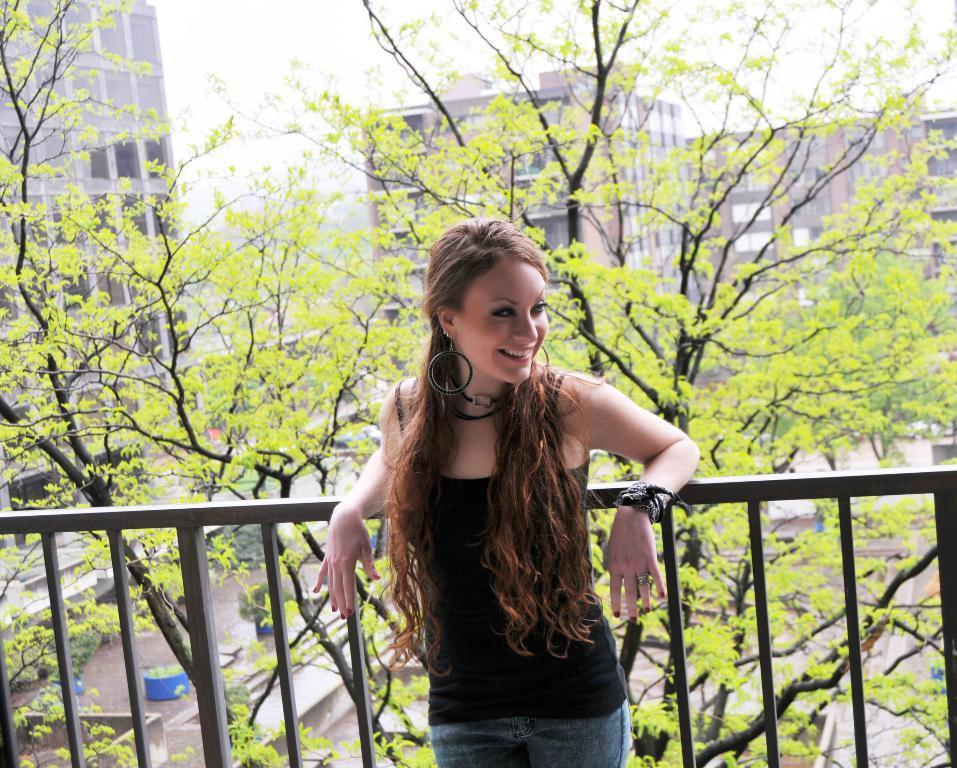What is the main subject of the image? There is a girl standing in the image. Where is the girl located in the image? The girl is at a fence. What can be seen in the background of the image? There are trees, buildings, plants in pots, and the sky visible in the background of the image. What type of seed is the girl planting in the image? There is no seed or planting activity depicted in the image; the girl is simply standing at a fence. Can you tell me where the nearest library is in relation to the girl in the image? The provided facts do not mention a library or its location in relation to the girl in the image. --- Facts: 1. There is a car in the image. 2. The car is parked on the street. 3. There are people walking on the sidewalk. 4. There are trees lining the street. 5. The sky is visible in the image. Absurd Topics: fish, volcano, parachute Conversation: What is the main subject of the image? There is a car in the image. Where is the car located in the image? The car is parked on the street. What else can be seen in the image besides the car? There are people walking on the sidewalk and trees lining the street. What is visible in the background of the image? The sky is visible in the image. Reasoning: Let's think step by step in order to produce the conversation. We start by identifying the main subject of the image, which is the car. Then, we describe the car's location, which is parked on the street. Next, we expand the conversation to include other elements visible in the image, such as people walking on the sidewalk, trees lining the street, and the sky. Each question is designed to elicit a specific detail about the image that is known from the provided facts. Absurd Question/Answer: Can you tell me how many fish are swimming in the car in the image? There are no fish present in the image; it features a car parked on the street. Is there a volcano erupting in the background of the image? There is no volcano or any indication of an eruption in the image; it features a car parked on the street with people walking on the sidewalk and trees lining the street, with the sky visible in the background. 